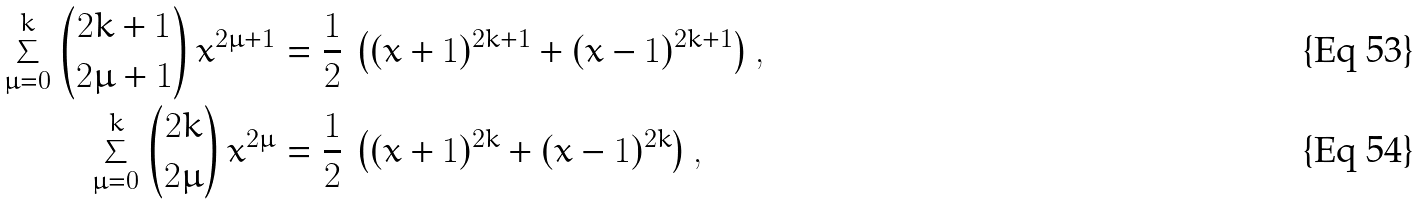<formula> <loc_0><loc_0><loc_500><loc_500>\sum _ { \mu = 0 } ^ { k } { 2 k + 1 \choose 2 \mu + 1 } \, x ^ { 2 \mu + 1 } & = \frac { 1 } { 2 } \, \left ( ( x + 1 ) ^ { 2 k + 1 } + ( x - 1 ) ^ { 2 k + 1 } \right ) , \\ \sum _ { \mu = 0 } ^ { k } { 2 k \choose 2 \mu } \, x ^ { 2 \mu } & = \frac { 1 } { 2 } \, \left ( ( x + 1 ) ^ { 2 k } + ( x - 1 ) ^ { 2 k } \right ) ,</formula> 